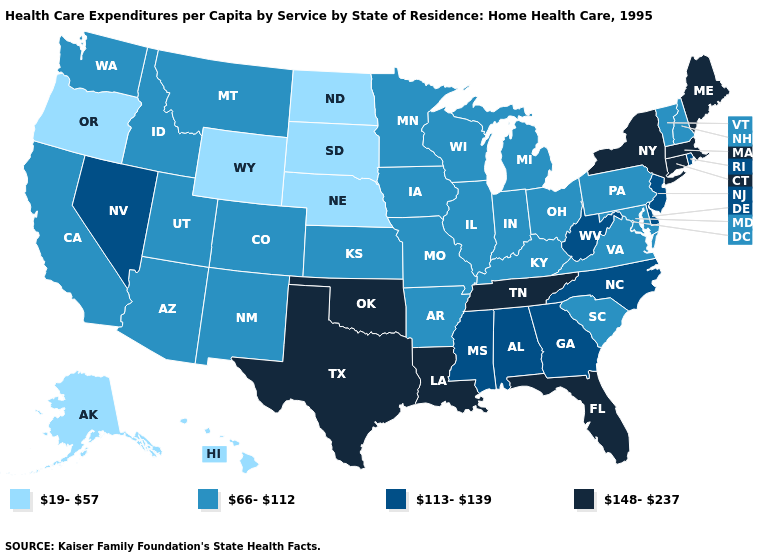Does North Carolina have the lowest value in the USA?
Give a very brief answer. No. Does California have a lower value than Florida?
Short answer required. Yes. What is the value of Missouri?
Be succinct. 66-112. What is the lowest value in the USA?
Write a very short answer. 19-57. Does Nevada have the highest value in the USA?
Write a very short answer. No. Does Hawaii have a lower value than Washington?
Give a very brief answer. Yes. Among the states that border New York , which have the highest value?
Keep it brief. Connecticut, Massachusetts. Name the states that have a value in the range 113-139?
Be succinct. Alabama, Delaware, Georgia, Mississippi, Nevada, New Jersey, North Carolina, Rhode Island, West Virginia. Name the states that have a value in the range 66-112?
Concise answer only. Arizona, Arkansas, California, Colorado, Idaho, Illinois, Indiana, Iowa, Kansas, Kentucky, Maryland, Michigan, Minnesota, Missouri, Montana, New Hampshire, New Mexico, Ohio, Pennsylvania, South Carolina, Utah, Vermont, Virginia, Washington, Wisconsin. What is the value of Michigan?
Answer briefly. 66-112. What is the lowest value in the MidWest?
Quick response, please. 19-57. Does Iowa have a lower value than Louisiana?
Give a very brief answer. Yes. Is the legend a continuous bar?
Concise answer only. No. Does New York have the highest value in the USA?
Write a very short answer. Yes. Among the states that border Arkansas , which have the highest value?
Short answer required. Louisiana, Oklahoma, Tennessee, Texas. 